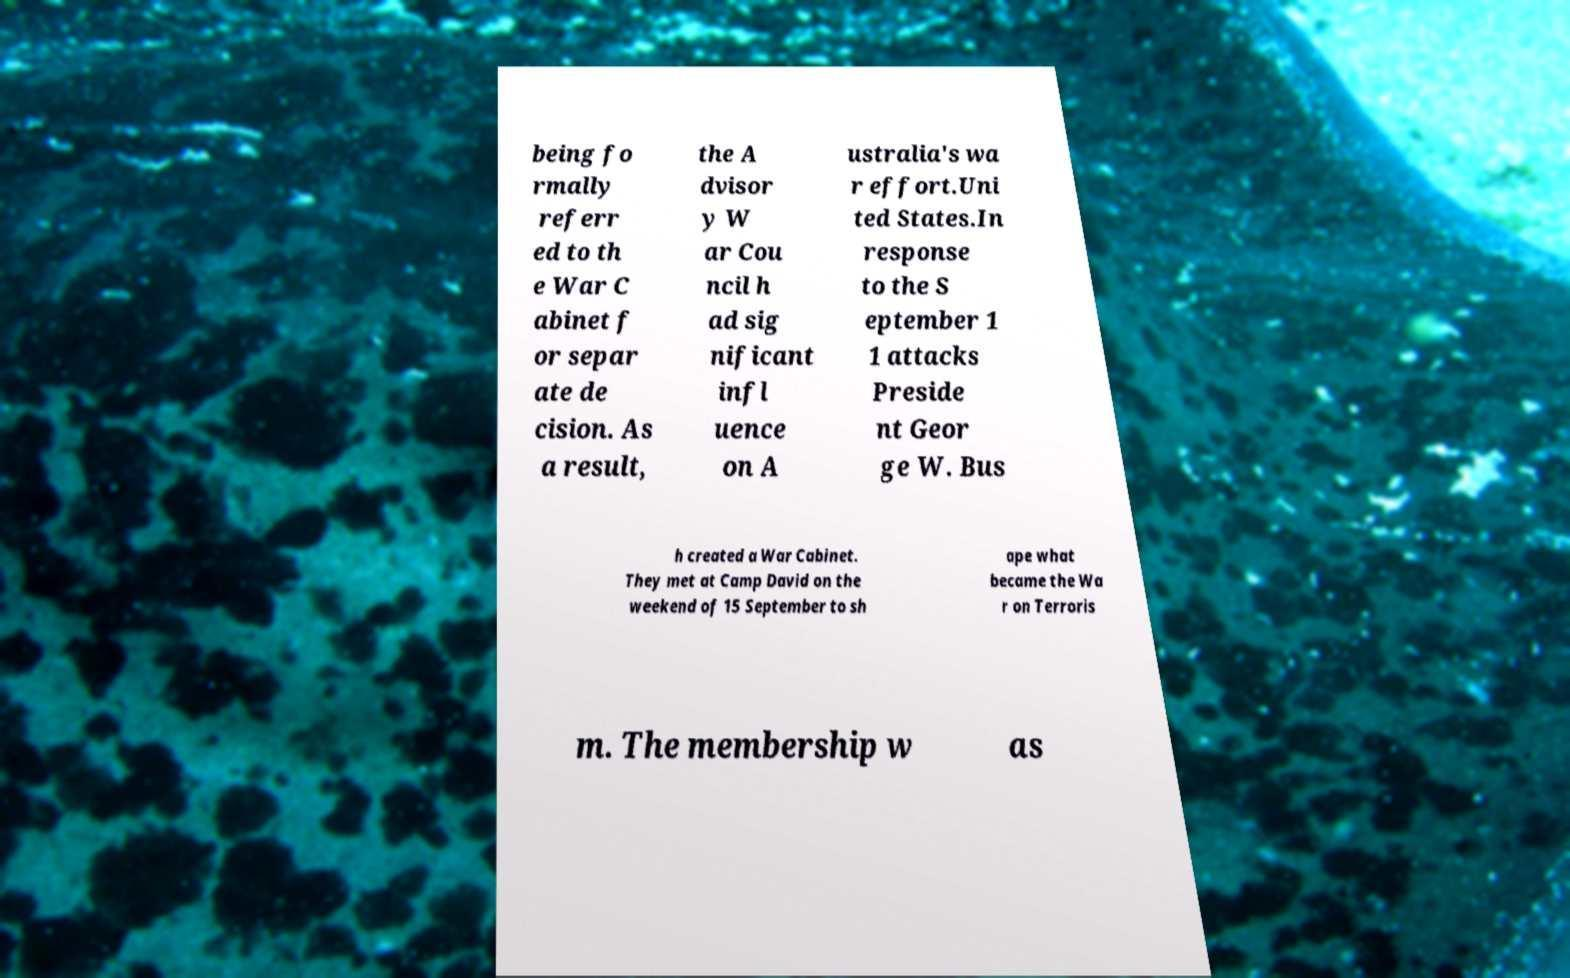Could you assist in decoding the text presented in this image and type it out clearly? being fo rmally referr ed to th e War C abinet f or separ ate de cision. As a result, the A dvisor y W ar Cou ncil h ad sig nificant infl uence on A ustralia's wa r effort.Uni ted States.In response to the S eptember 1 1 attacks Preside nt Geor ge W. Bus h created a War Cabinet. They met at Camp David on the weekend of 15 September to sh ape what became the Wa r on Terroris m. The membership w as 